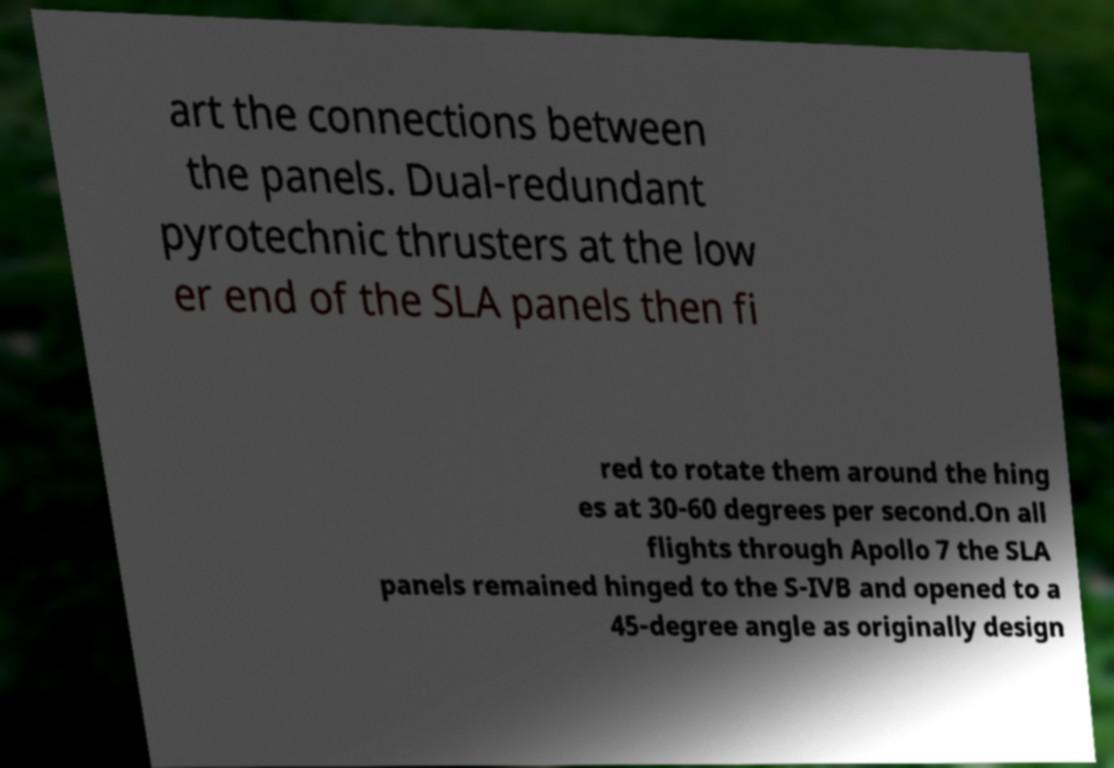Can you accurately transcribe the text from the provided image for me? art the connections between the panels. Dual-redundant pyrotechnic thrusters at the low er end of the SLA panels then fi red to rotate them around the hing es at 30-60 degrees per second.On all flights through Apollo 7 the SLA panels remained hinged to the S-IVB and opened to a 45-degree angle as originally design 